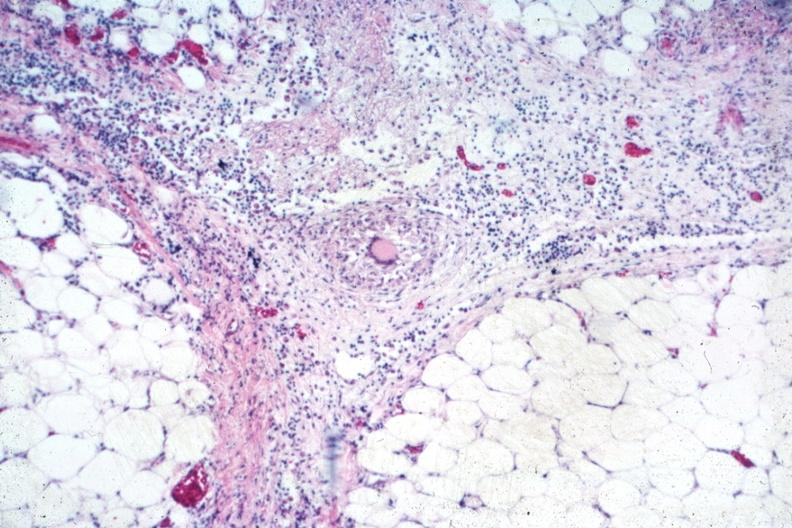what does this image show?
Answer the question using a single word or phrase. Outstanding example of granuloma with langhans giant cell 